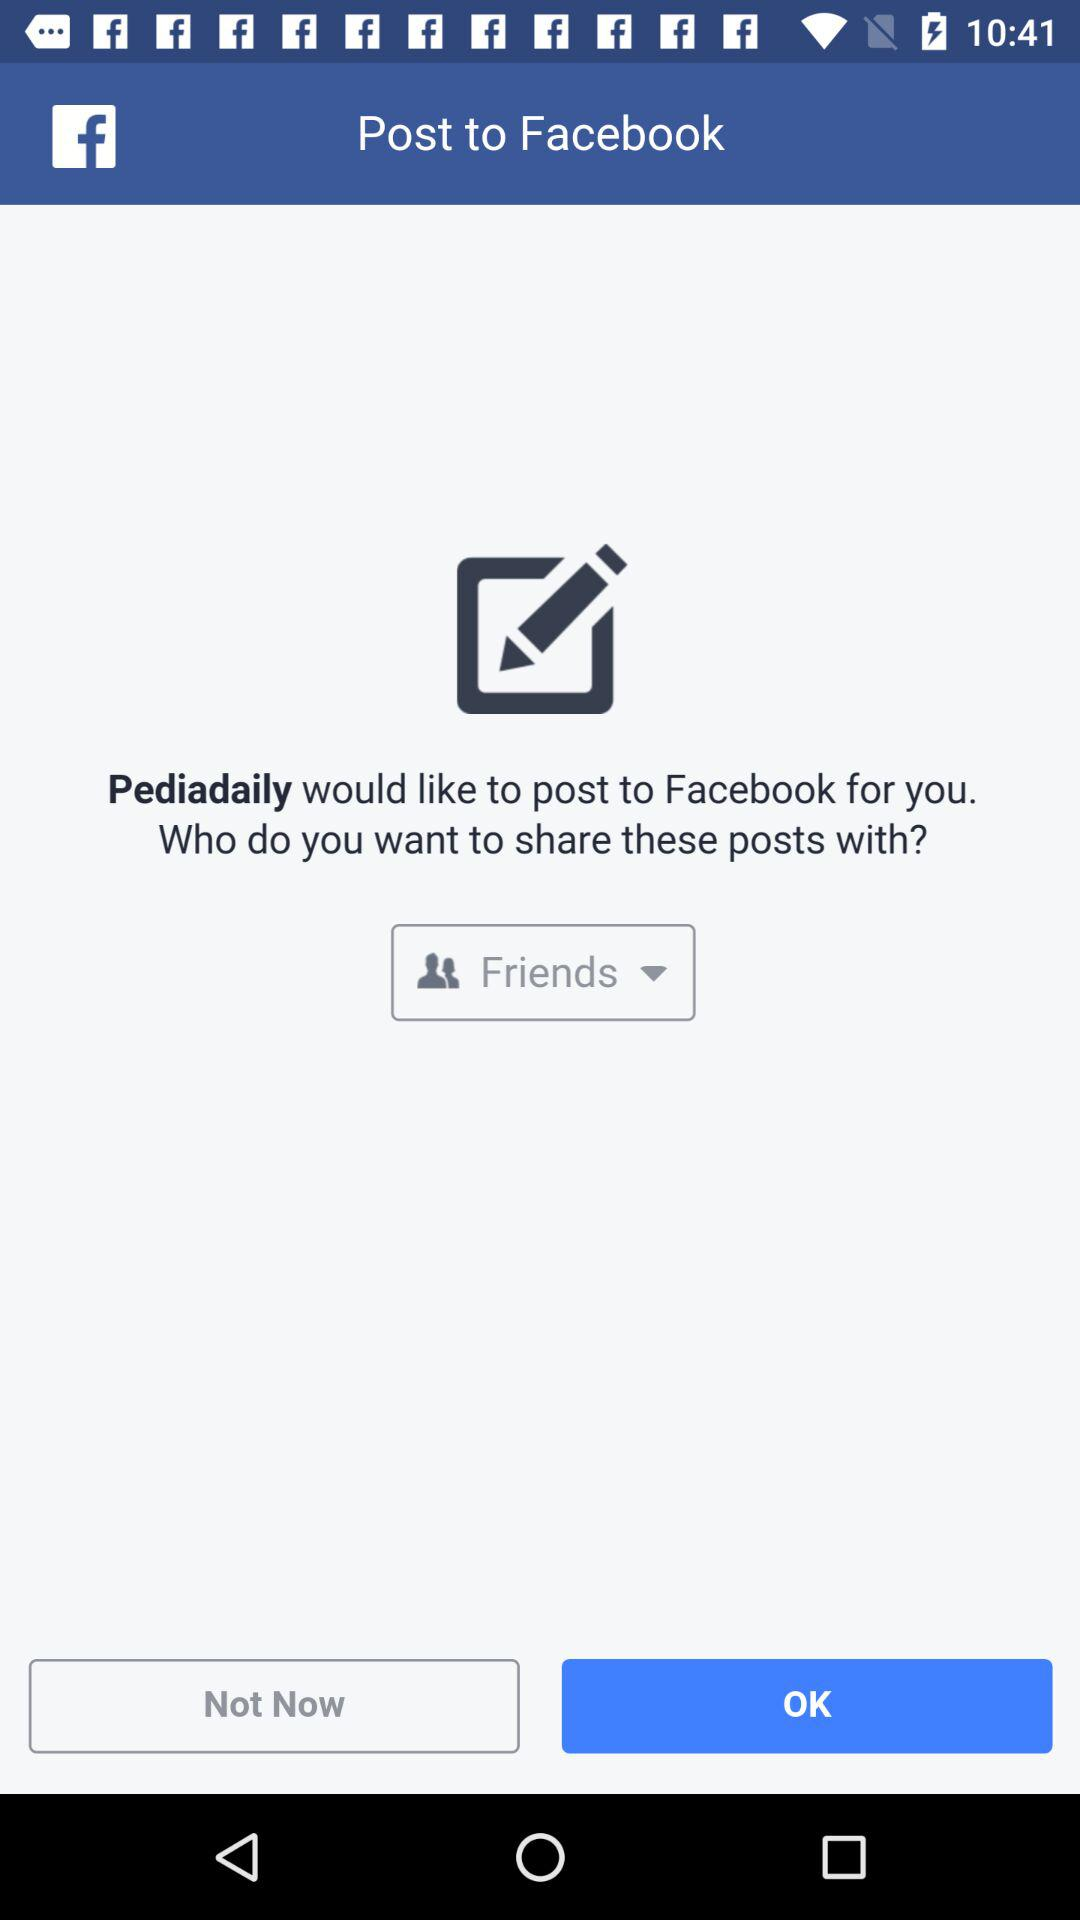What application wants to post to "Facebook"? The application that wants to post to "Facebook" is "Pediadaily". 